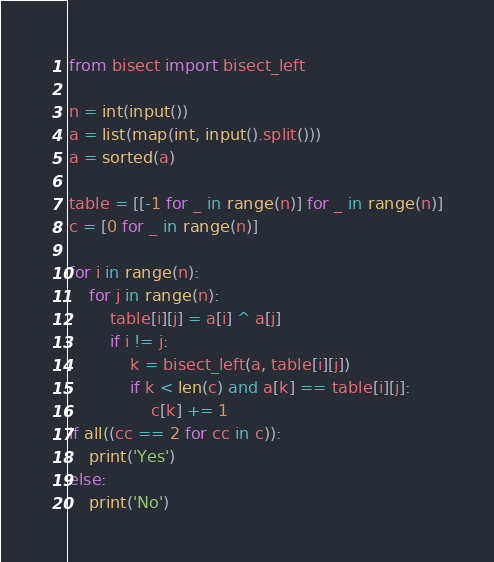Convert code to text. <code><loc_0><loc_0><loc_500><loc_500><_Python_>from bisect import bisect_left

n = int(input())
a = list(map(int, input().split()))
a = sorted(a)

table = [[-1 for _ in range(n)] for _ in range(n)]
c = [0 for _ in range(n)]

for i in range(n):
    for j in range(n):
        table[i][j] = a[i] ^ a[j]
        if i != j:
            k = bisect_left(a, table[i][j])
            if k < len(c) and a[k] == table[i][j]:
                c[k] += 1
if all((cc == 2 for cc in c)):
    print('Yes')
else:
    print('No')

</code> 